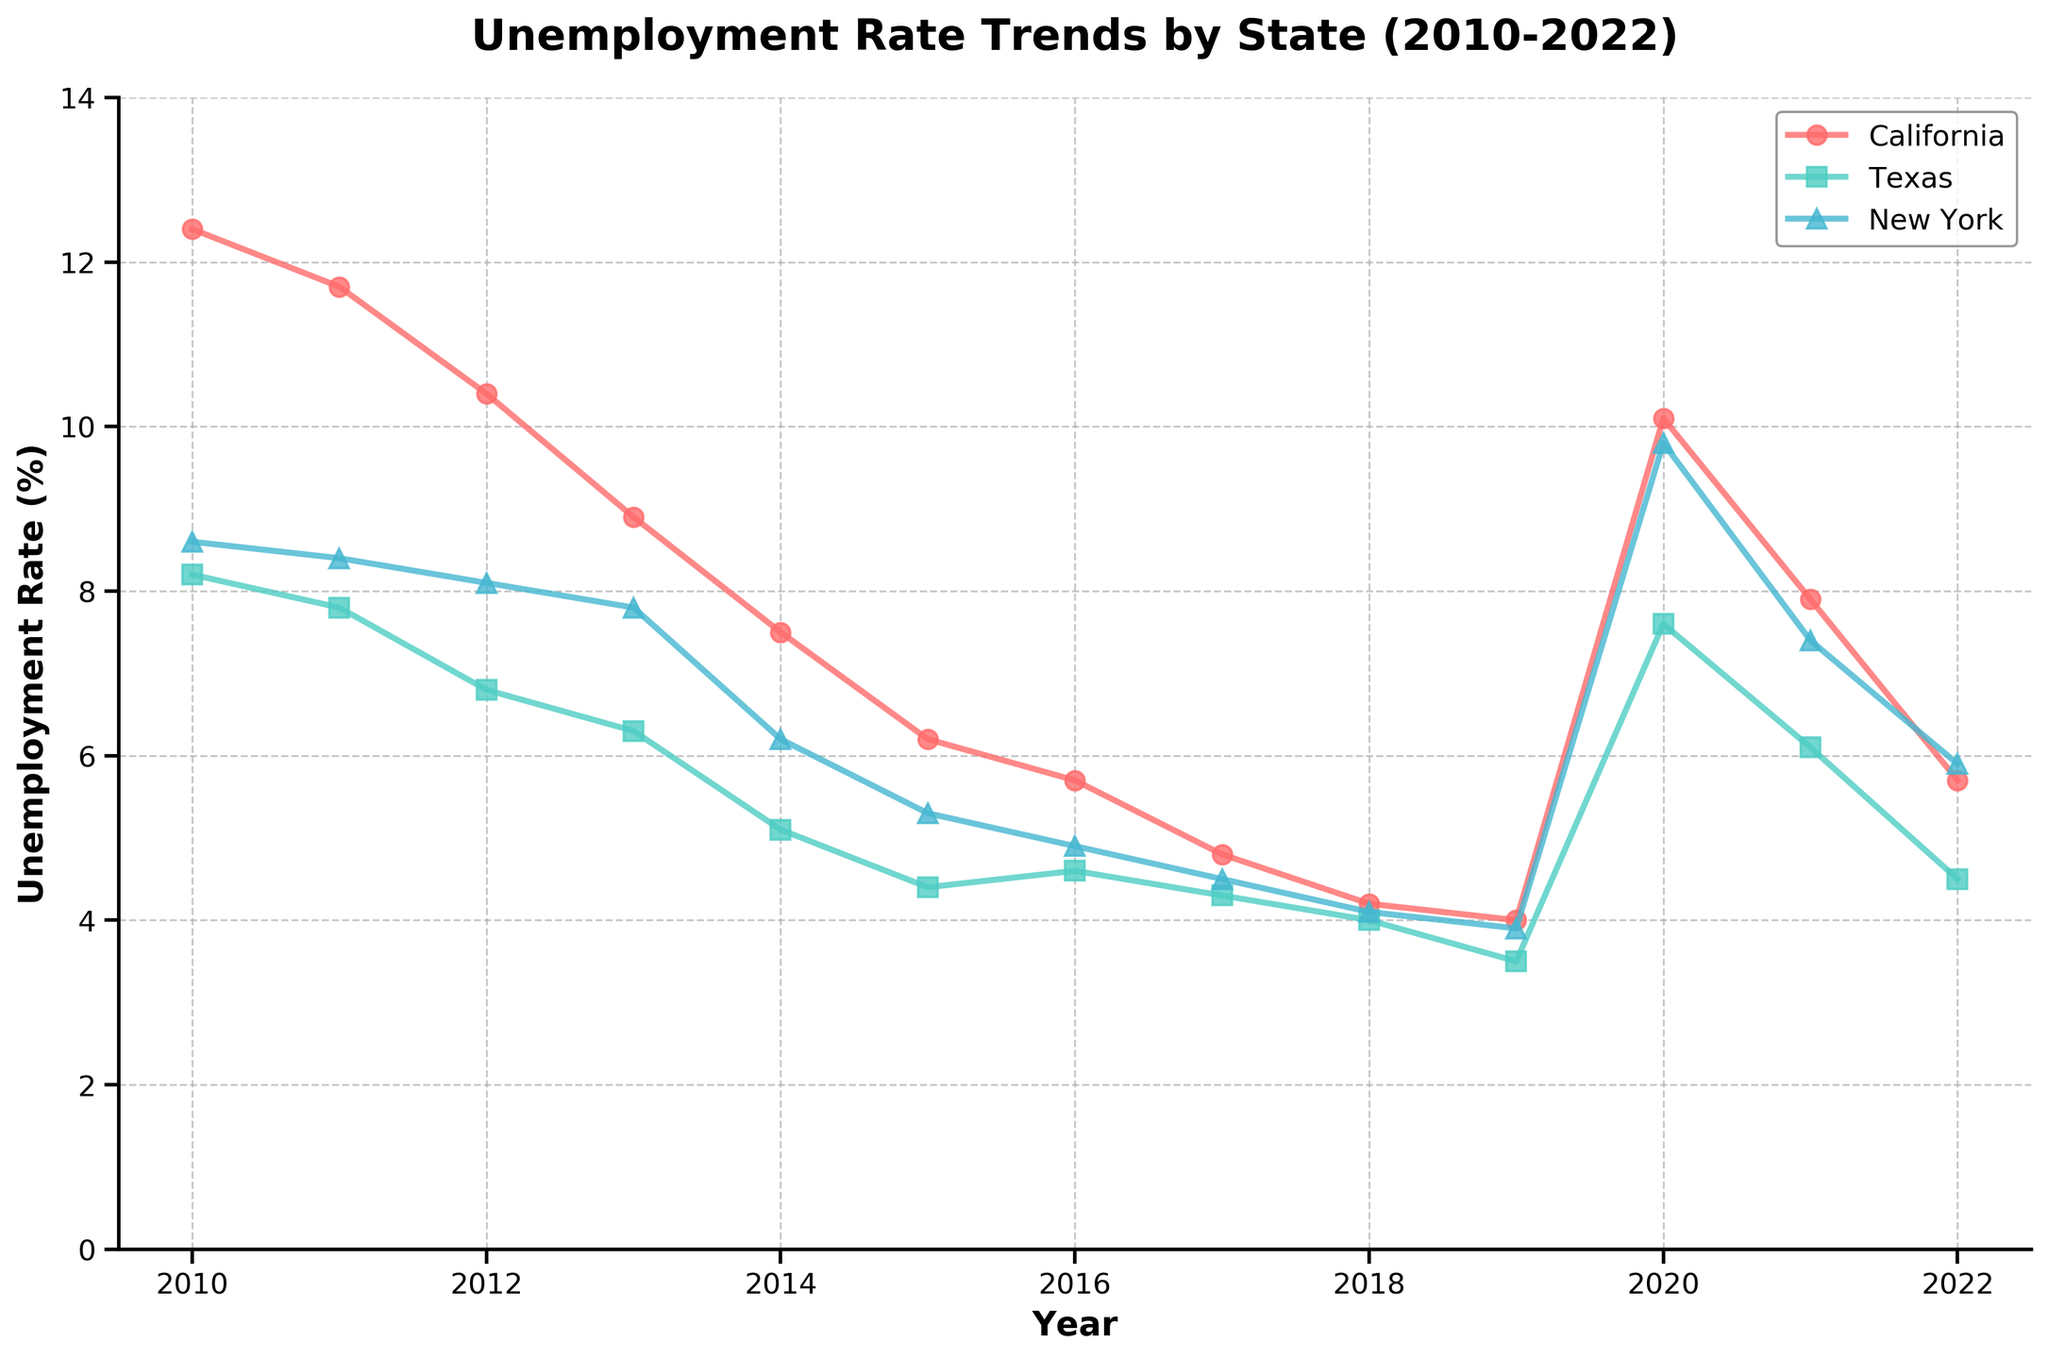What is the title of the plot? The title of the plot is mentioned at the top center of the figure. It reads "Unemployment Rate Trends by State (2010-2022)".
Answer: Unemployment Rate Trends by State (2010-2022) What is the trend of unemployment rate in California from 2010 to 2022? The line for California starts at a high point of 12.4% in 2010, decreases over the years reaching a low of 4.0% in 2019, spikes again in 2020 reaching 10.1%, and then decreases back to 5.7% by 2022.
Answer: Decreases overall with a spike in 2020 Which state had the highest unemployment rate in 2010? By comparing the starting points of the lines in 2010, it's evident that California has the highest unemployment rate at 12.4%.
Answer: California What is the difference in the unemployment rate of Texas between 2010 and 2012? The unemployment rate in Texas was 8.2% in 2010 and 6.8% in 2012. The difference is calculated as 8.2% - 6.8% = 1.4%.
Answer: 1.4% In which year did New York have its lowest unemployment rate, and what was the rate? By examining the line for New York, the lowest point is in 2019, where the unemployment rate was 3.9%.
Answer: 2019, 3.9% Compare the unemployment trends in California and Texas in 2020. Which state saw a more significant increase, and by how much? In 2020, California's unemployment rate increased from 4.0% in 2019 to 10.1%, which is an increase of 6.1%. Texas saw an increase from 3.5% to 7.6%, which is an increase of 4.1%. Therefore, California saw a more significant increase by 6.1% - 4.1% = 2.0%.
Answer: California, 2.0% What was the average unemployment rate in New York over the years 2010 to 2022? Summing up the unemployment rates for New York from 2010 to 2022 (8.6, 8.4, 8.1, 7.8, 6.2, 5.3, 4.9, 4.5, 4.1, 3.9, 9.8, 7.4, 5.9) and dividing by the number of years (13) gives (8.6 + 8.4 + 8.1 + 7.8 + 6.2 + 5.3 + 4.9 + 4.5 + 4.1 + 3.9 + 9.8 + 7.4 + 5.9) / 13 = 88.9 / 13 ≈ 6.84%.
Answer: 6.84% In 2018, were the unemployment rates of all three states close to each other? All three states showed similar unemployment rates in 2018, with California at 4.2%, Texas at 4.0%, and New York at 4.1%. The difference between the highest and lowest rates is 4.2% - 4.0% = 0.2%.
Answer: Yes Which state had the most stable unemployment rate from 2010 to 2022? Observing the lines, Texas shows the least variation over the years, without significant spikes and maintaining a relatively stable trend.
Answer: Texas After 2019, how did the unemployment rates for the three states change? Post-2019, all states saw unemployment increases in 2020 due to economic factors like the pandemic. California increased to 10.1%, Texas to 7.6%, and New York to 9.8%. Then, the rates decreased in subsequent years for all three states.
Answer: Increased in 2020, then decreased 